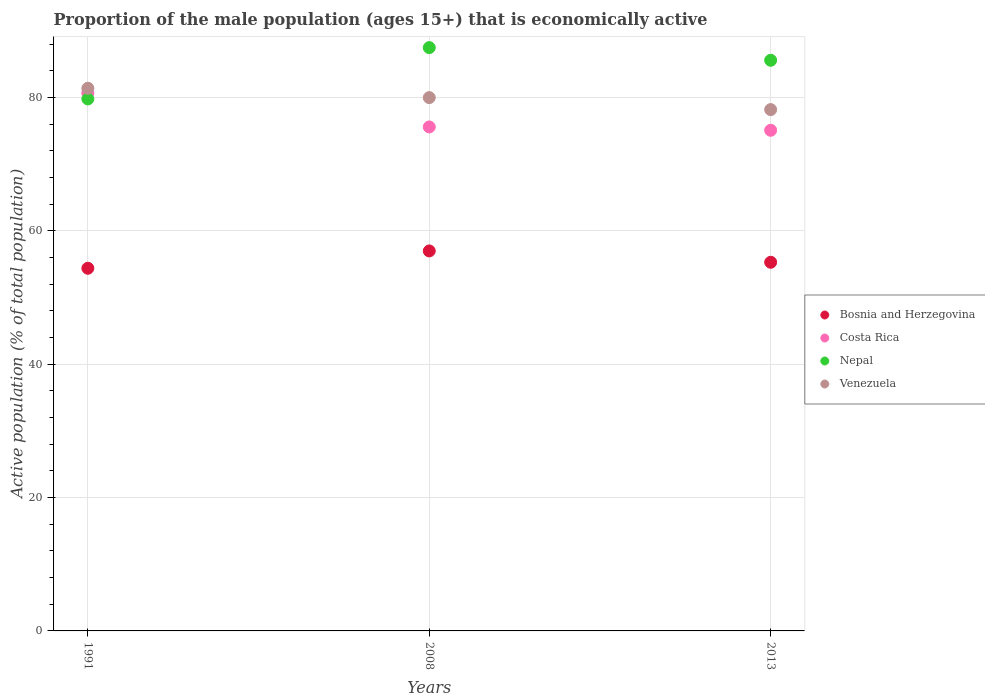How many different coloured dotlines are there?
Your answer should be very brief. 4. What is the proportion of the male population that is economically active in Venezuela in 2013?
Give a very brief answer. 78.2. Across all years, what is the maximum proportion of the male population that is economically active in Costa Rica?
Give a very brief answer. 80.7. Across all years, what is the minimum proportion of the male population that is economically active in Venezuela?
Provide a succinct answer. 78.2. In which year was the proportion of the male population that is economically active in Nepal maximum?
Provide a short and direct response. 2008. What is the total proportion of the male population that is economically active in Bosnia and Herzegovina in the graph?
Provide a succinct answer. 166.7. What is the difference between the proportion of the male population that is economically active in Venezuela in 1991 and that in 2008?
Your response must be concise. 1.4. What is the difference between the proportion of the male population that is economically active in Costa Rica in 2013 and the proportion of the male population that is economically active in Nepal in 2008?
Offer a very short reply. -12.4. What is the average proportion of the male population that is economically active in Bosnia and Herzegovina per year?
Provide a short and direct response. 55.57. In the year 1991, what is the difference between the proportion of the male population that is economically active in Nepal and proportion of the male population that is economically active in Venezuela?
Give a very brief answer. -1.6. In how many years, is the proportion of the male population that is economically active in Nepal greater than 4 %?
Ensure brevity in your answer.  3. What is the ratio of the proportion of the male population that is economically active in Venezuela in 1991 to that in 2013?
Offer a terse response. 1.04. Is the difference between the proportion of the male population that is economically active in Nepal in 1991 and 2013 greater than the difference between the proportion of the male population that is economically active in Venezuela in 1991 and 2013?
Provide a succinct answer. No. What is the difference between the highest and the second highest proportion of the male population that is economically active in Venezuela?
Ensure brevity in your answer.  1.4. What is the difference between the highest and the lowest proportion of the male population that is economically active in Venezuela?
Provide a short and direct response. 3.2. In how many years, is the proportion of the male population that is economically active in Bosnia and Herzegovina greater than the average proportion of the male population that is economically active in Bosnia and Herzegovina taken over all years?
Your answer should be very brief. 1. Is it the case that in every year, the sum of the proportion of the male population that is economically active in Venezuela and proportion of the male population that is economically active in Costa Rica  is greater than the sum of proportion of the male population that is economically active in Bosnia and Herzegovina and proportion of the male population that is economically active in Nepal?
Provide a short and direct response. No. Is the proportion of the male population that is economically active in Bosnia and Herzegovina strictly greater than the proportion of the male population that is economically active in Venezuela over the years?
Your answer should be very brief. No. How many dotlines are there?
Your answer should be very brief. 4. Does the graph contain any zero values?
Offer a very short reply. No. How many legend labels are there?
Ensure brevity in your answer.  4. How are the legend labels stacked?
Your answer should be compact. Vertical. What is the title of the graph?
Ensure brevity in your answer.  Proportion of the male population (ages 15+) that is economically active. Does "Nicaragua" appear as one of the legend labels in the graph?
Provide a succinct answer. No. What is the label or title of the X-axis?
Give a very brief answer. Years. What is the label or title of the Y-axis?
Offer a terse response. Active population (% of total population). What is the Active population (% of total population) in Bosnia and Herzegovina in 1991?
Give a very brief answer. 54.4. What is the Active population (% of total population) of Costa Rica in 1991?
Provide a short and direct response. 80.7. What is the Active population (% of total population) in Nepal in 1991?
Offer a very short reply. 79.8. What is the Active population (% of total population) in Venezuela in 1991?
Offer a very short reply. 81.4. What is the Active population (% of total population) of Costa Rica in 2008?
Your answer should be very brief. 75.6. What is the Active population (% of total population) in Nepal in 2008?
Ensure brevity in your answer.  87.5. What is the Active population (% of total population) in Bosnia and Herzegovina in 2013?
Make the answer very short. 55.3. What is the Active population (% of total population) of Costa Rica in 2013?
Your answer should be compact. 75.1. What is the Active population (% of total population) of Nepal in 2013?
Ensure brevity in your answer.  85.6. What is the Active population (% of total population) of Venezuela in 2013?
Your response must be concise. 78.2. Across all years, what is the maximum Active population (% of total population) of Bosnia and Herzegovina?
Make the answer very short. 57. Across all years, what is the maximum Active population (% of total population) of Costa Rica?
Your answer should be very brief. 80.7. Across all years, what is the maximum Active population (% of total population) of Nepal?
Keep it short and to the point. 87.5. Across all years, what is the maximum Active population (% of total population) of Venezuela?
Your answer should be compact. 81.4. Across all years, what is the minimum Active population (% of total population) in Bosnia and Herzegovina?
Ensure brevity in your answer.  54.4. Across all years, what is the minimum Active population (% of total population) of Costa Rica?
Provide a succinct answer. 75.1. Across all years, what is the minimum Active population (% of total population) of Nepal?
Provide a succinct answer. 79.8. Across all years, what is the minimum Active population (% of total population) of Venezuela?
Your answer should be compact. 78.2. What is the total Active population (% of total population) in Bosnia and Herzegovina in the graph?
Offer a very short reply. 166.7. What is the total Active population (% of total population) of Costa Rica in the graph?
Make the answer very short. 231.4. What is the total Active population (% of total population) of Nepal in the graph?
Keep it short and to the point. 252.9. What is the total Active population (% of total population) in Venezuela in the graph?
Keep it short and to the point. 239.6. What is the difference between the Active population (% of total population) of Bosnia and Herzegovina in 1991 and that in 2008?
Your response must be concise. -2.6. What is the difference between the Active population (% of total population) of Costa Rica in 1991 and that in 2008?
Offer a very short reply. 5.1. What is the difference between the Active population (% of total population) of Nepal in 1991 and that in 2008?
Your answer should be compact. -7.7. What is the difference between the Active population (% of total population) of Venezuela in 1991 and that in 2008?
Keep it short and to the point. 1.4. What is the difference between the Active population (% of total population) of Nepal in 1991 and that in 2013?
Make the answer very short. -5.8. What is the difference between the Active population (% of total population) of Venezuela in 1991 and that in 2013?
Provide a short and direct response. 3.2. What is the difference between the Active population (% of total population) in Bosnia and Herzegovina in 2008 and that in 2013?
Your response must be concise. 1.7. What is the difference between the Active population (% of total population) of Costa Rica in 2008 and that in 2013?
Your response must be concise. 0.5. What is the difference between the Active population (% of total population) in Bosnia and Herzegovina in 1991 and the Active population (% of total population) in Costa Rica in 2008?
Your answer should be very brief. -21.2. What is the difference between the Active population (% of total population) in Bosnia and Herzegovina in 1991 and the Active population (% of total population) in Nepal in 2008?
Offer a terse response. -33.1. What is the difference between the Active population (% of total population) of Bosnia and Herzegovina in 1991 and the Active population (% of total population) of Venezuela in 2008?
Give a very brief answer. -25.6. What is the difference between the Active population (% of total population) of Costa Rica in 1991 and the Active population (% of total population) of Venezuela in 2008?
Provide a short and direct response. 0.7. What is the difference between the Active population (% of total population) in Nepal in 1991 and the Active population (% of total population) in Venezuela in 2008?
Your answer should be compact. -0.2. What is the difference between the Active population (% of total population) of Bosnia and Herzegovina in 1991 and the Active population (% of total population) of Costa Rica in 2013?
Offer a very short reply. -20.7. What is the difference between the Active population (% of total population) of Bosnia and Herzegovina in 1991 and the Active population (% of total population) of Nepal in 2013?
Offer a very short reply. -31.2. What is the difference between the Active population (% of total population) in Bosnia and Herzegovina in 1991 and the Active population (% of total population) in Venezuela in 2013?
Make the answer very short. -23.8. What is the difference between the Active population (% of total population) of Costa Rica in 1991 and the Active population (% of total population) of Nepal in 2013?
Make the answer very short. -4.9. What is the difference between the Active population (% of total population) in Costa Rica in 1991 and the Active population (% of total population) in Venezuela in 2013?
Ensure brevity in your answer.  2.5. What is the difference between the Active population (% of total population) in Nepal in 1991 and the Active population (% of total population) in Venezuela in 2013?
Your response must be concise. 1.6. What is the difference between the Active population (% of total population) in Bosnia and Herzegovina in 2008 and the Active population (% of total population) in Costa Rica in 2013?
Ensure brevity in your answer.  -18.1. What is the difference between the Active population (% of total population) in Bosnia and Herzegovina in 2008 and the Active population (% of total population) in Nepal in 2013?
Offer a very short reply. -28.6. What is the difference between the Active population (% of total population) of Bosnia and Herzegovina in 2008 and the Active population (% of total population) of Venezuela in 2013?
Provide a succinct answer. -21.2. What is the difference between the Active population (% of total population) of Costa Rica in 2008 and the Active population (% of total population) of Nepal in 2013?
Provide a short and direct response. -10. What is the difference between the Active population (% of total population) of Costa Rica in 2008 and the Active population (% of total population) of Venezuela in 2013?
Keep it short and to the point. -2.6. What is the difference between the Active population (% of total population) of Nepal in 2008 and the Active population (% of total population) of Venezuela in 2013?
Give a very brief answer. 9.3. What is the average Active population (% of total population) of Bosnia and Herzegovina per year?
Offer a terse response. 55.57. What is the average Active population (% of total population) of Costa Rica per year?
Your response must be concise. 77.13. What is the average Active population (% of total population) of Nepal per year?
Make the answer very short. 84.3. What is the average Active population (% of total population) in Venezuela per year?
Your answer should be compact. 79.87. In the year 1991, what is the difference between the Active population (% of total population) of Bosnia and Herzegovina and Active population (% of total population) of Costa Rica?
Ensure brevity in your answer.  -26.3. In the year 1991, what is the difference between the Active population (% of total population) in Bosnia and Herzegovina and Active population (% of total population) in Nepal?
Keep it short and to the point. -25.4. In the year 1991, what is the difference between the Active population (% of total population) of Bosnia and Herzegovina and Active population (% of total population) of Venezuela?
Your answer should be very brief. -27. In the year 1991, what is the difference between the Active population (% of total population) of Costa Rica and Active population (% of total population) of Nepal?
Offer a very short reply. 0.9. In the year 1991, what is the difference between the Active population (% of total population) of Nepal and Active population (% of total population) of Venezuela?
Provide a succinct answer. -1.6. In the year 2008, what is the difference between the Active population (% of total population) of Bosnia and Herzegovina and Active population (% of total population) of Costa Rica?
Your response must be concise. -18.6. In the year 2008, what is the difference between the Active population (% of total population) of Bosnia and Herzegovina and Active population (% of total population) of Nepal?
Make the answer very short. -30.5. In the year 2008, what is the difference between the Active population (% of total population) in Bosnia and Herzegovina and Active population (% of total population) in Venezuela?
Ensure brevity in your answer.  -23. In the year 2013, what is the difference between the Active population (% of total population) of Bosnia and Herzegovina and Active population (% of total population) of Costa Rica?
Your response must be concise. -19.8. In the year 2013, what is the difference between the Active population (% of total population) in Bosnia and Herzegovina and Active population (% of total population) in Nepal?
Ensure brevity in your answer.  -30.3. In the year 2013, what is the difference between the Active population (% of total population) in Bosnia and Herzegovina and Active population (% of total population) in Venezuela?
Provide a succinct answer. -22.9. In the year 2013, what is the difference between the Active population (% of total population) in Costa Rica and Active population (% of total population) in Venezuela?
Offer a very short reply. -3.1. In the year 2013, what is the difference between the Active population (% of total population) in Nepal and Active population (% of total population) in Venezuela?
Make the answer very short. 7.4. What is the ratio of the Active population (% of total population) in Bosnia and Herzegovina in 1991 to that in 2008?
Your response must be concise. 0.95. What is the ratio of the Active population (% of total population) in Costa Rica in 1991 to that in 2008?
Make the answer very short. 1.07. What is the ratio of the Active population (% of total population) of Nepal in 1991 to that in 2008?
Provide a short and direct response. 0.91. What is the ratio of the Active population (% of total population) in Venezuela in 1991 to that in 2008?
Ensure brevity in your answer.  1.02. What is the ratio of the Active population (% of total population) in Bosnia and Herzegovina in 1991 to that in 2013?
Offer a very short reply. 0.98. What is the ratio of the Active population (% of total population) in Costa Rica in 1991 to that in 2013?
Offer a terse response. 1.07. What is the ratio of the Active population (% of total population) of Nepal in 1991 to that in 2013?
Give a very brief answer. 0.93. What is the ratio of the Active population (% of total population) of Venezuela in 1991 to that in 2013?
Your answer should be compact. 1.04. What is the ratio of the Active population (% of total population) of Bosnia and Herzegovina in 2008 to that in 2013?
Provide a short and direct response. 1.03. What is the ratio of the Active population (% of total population) in Nepal in 2008 to that in 2013?
Give a very brief answer. 1.02. What is the difference between the highest and the second highest Active population (% of total population) in Costa Rica?
Your response must be concise. 5.1. What is the difference between the highest and the second highest Active population (% of total population) of Venezuela?
Ensure brevity in your answer.  1.4. What is the difference between the highest and the lowest Active population (% of total population) in Nepal?
Offer a terse response. 7.7. What is the difference between the highest and the lowest Active population (% of total population) of Venezuela?
Your answer should be very brief. 3.2. 